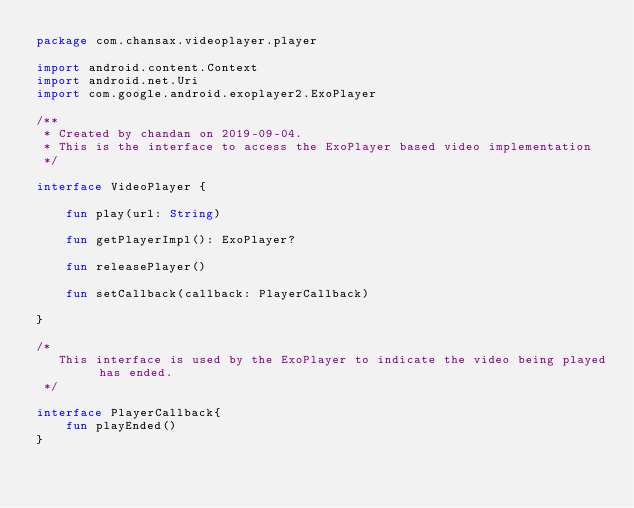<code> <loc_0><loc_0><loc_500><loc_500><_Kotlin_>package com.chansax.videoplayer.player

import android.content.Context
import android.net.Uri
import com.google.android.exoplayer2.ExoPlayer

/**
 * Created by chandan on 2019-09-04.
 * This is the interface to access the ExoPlayer based video implementation
 */

interface VideoPlayer {

    fun play(url: String)

    fun getPlayerImpl(): ExoPlayer?

    fun releasePlayer()

    fun setCallback(callback: PlayerCallback)

}

/*
   This interface is used by the ExoPlayer to indicate the video being played has ended.
 */

interface PlayerCallback{
    fun playEnded()
}</code> 